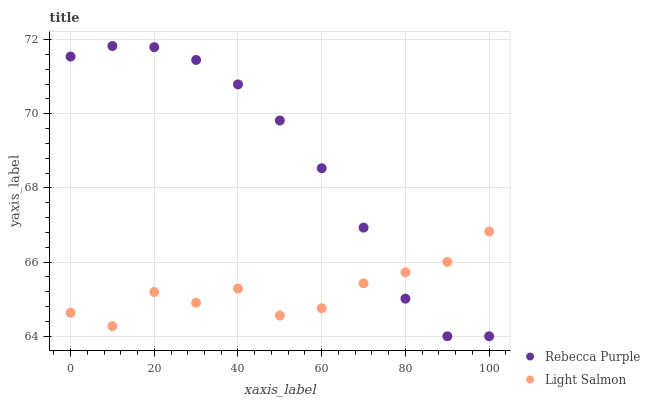Does Light Salmon have the minimum area under the curve?
Answer yes or no. Yes. Does Rebecca Purple have the maximum area under the curve?
Answer yes or no. Yes. Does Rebecca Purple have the minimum area under the curve?
Answer yes or no. No. Is Rebecca Purple the smoothest?
Answer yes or no. Yes. Is Light Salmon the roughest?
Answer yes or no. Yes. Is Rebecca Purple the roughest?
Answer yes or no. No. Does Rebecca Purple have the lowest value?
Answer yes or no. Yes. Does Rebecca Purple have the highest value?
Answer yes or no. Yes. Does Light Salmon intersect Rebecca Purple?
Answer yes or no. Yes. Is Light Salmon less than Rebecca Purple?
Answer yes or no. No. Is Light Salmon greater than Rebecca Purple?
Answer yes or no. No. 